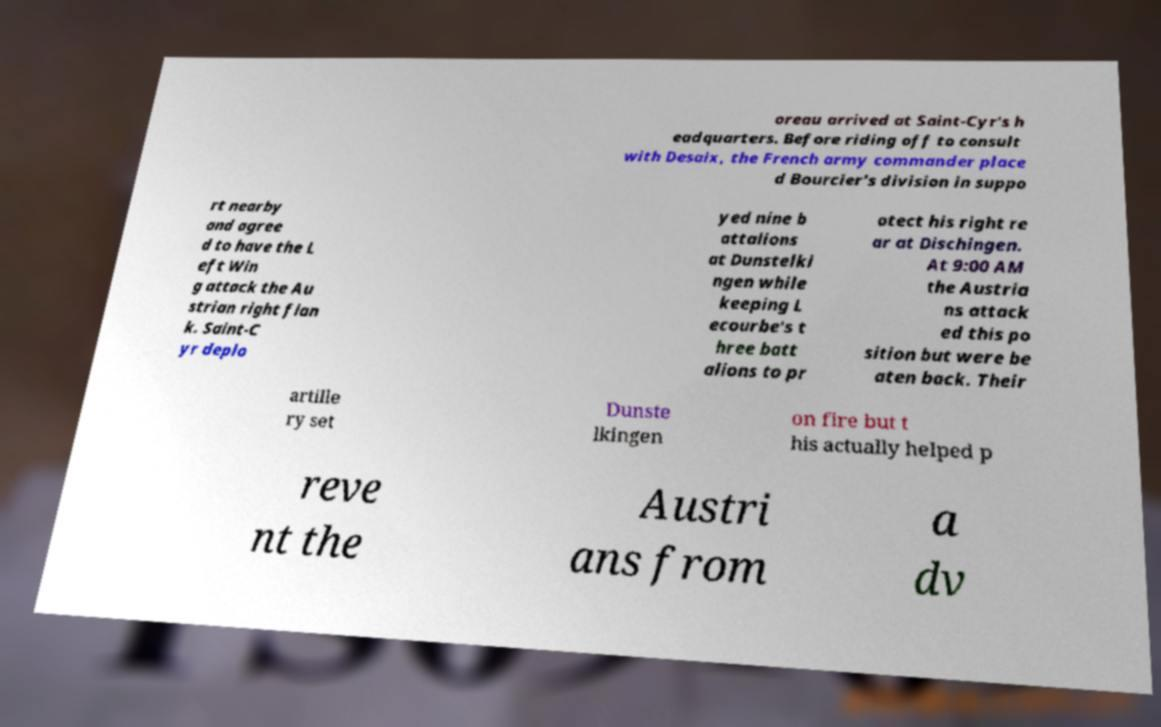Please identify and transcribe the text found in this image. oreau arrived at Saint-Cyr's h eadquarters. Before riding off to consult with Desaix, the French army commander place d Bourcier's division in suppo rt nearby and agree d to have the L eft Win g attack the Au strian right flan k. Saint-C yr deplo yed nine b attalions at Dunstelki ngen while keeping L ecourbe's t hree batt alions to pr otect his right re ar at Dischingen. At 9:00 AM the Austria ns attack ed this po sition but were be aten back. Their artille ry set Dunste lkingen on fire but t his actually helped p reve nt the Austri ans from a dv 